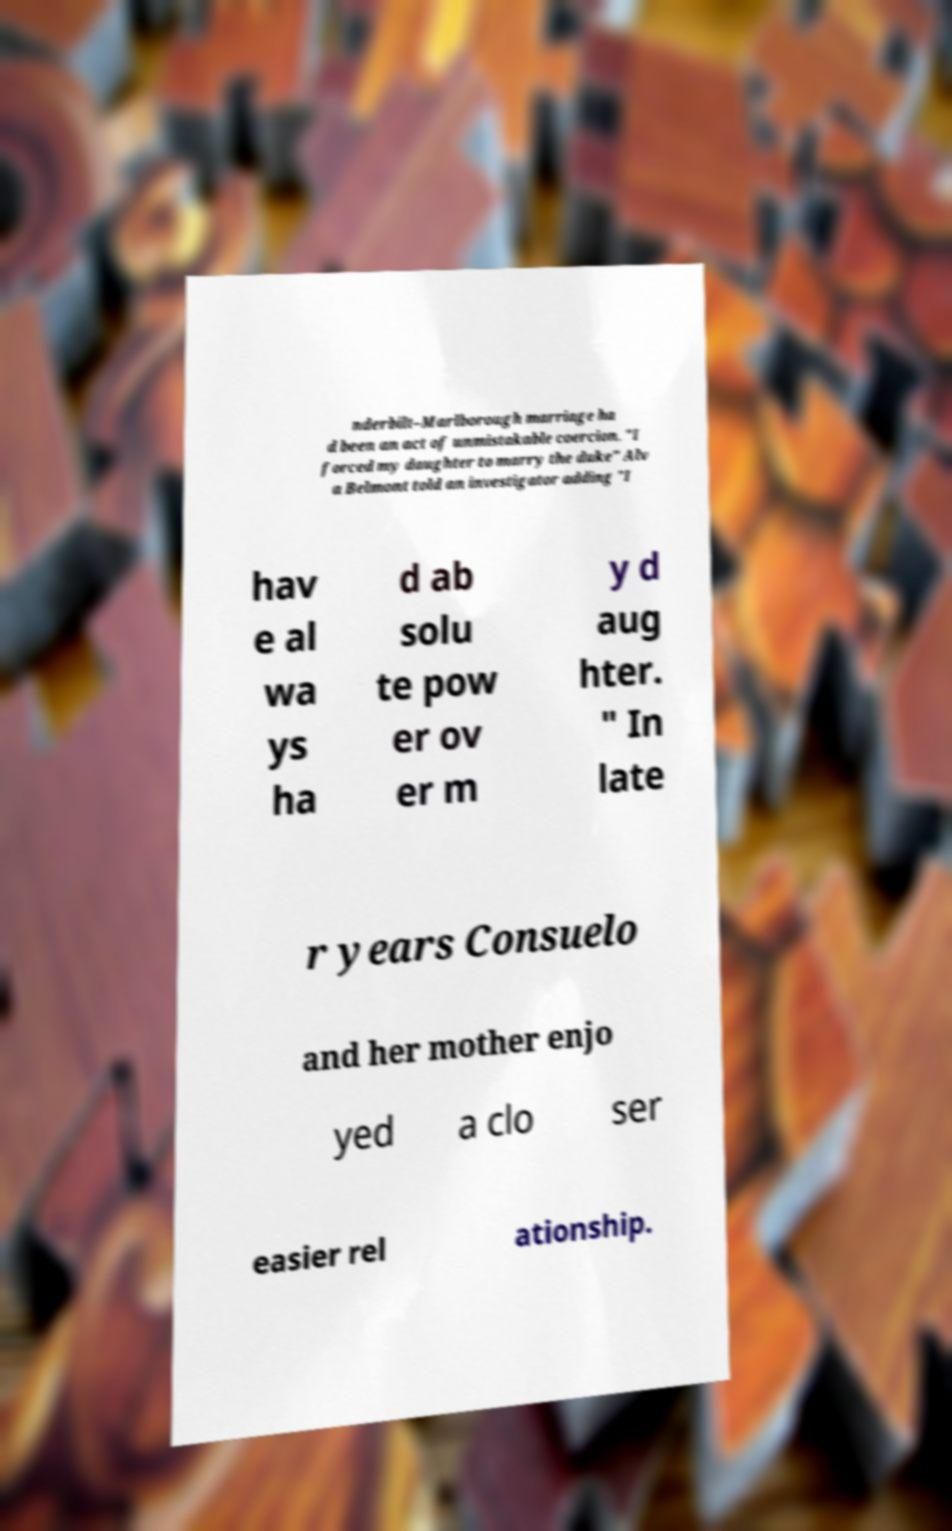I need the written content from this picture converted into text. Can you do that? nderbilt–Marlborough marriage ha d been an act of unmistakable coercion. "I forced my daughter to marry the duke" Alv a Belmont told an investigator adding "I hav e al wa ys ha d ab solu te pow er ov er m y d aug hter. " In late r years Consuelo and her mother enjo yed a clo ser easier rel ationship. 